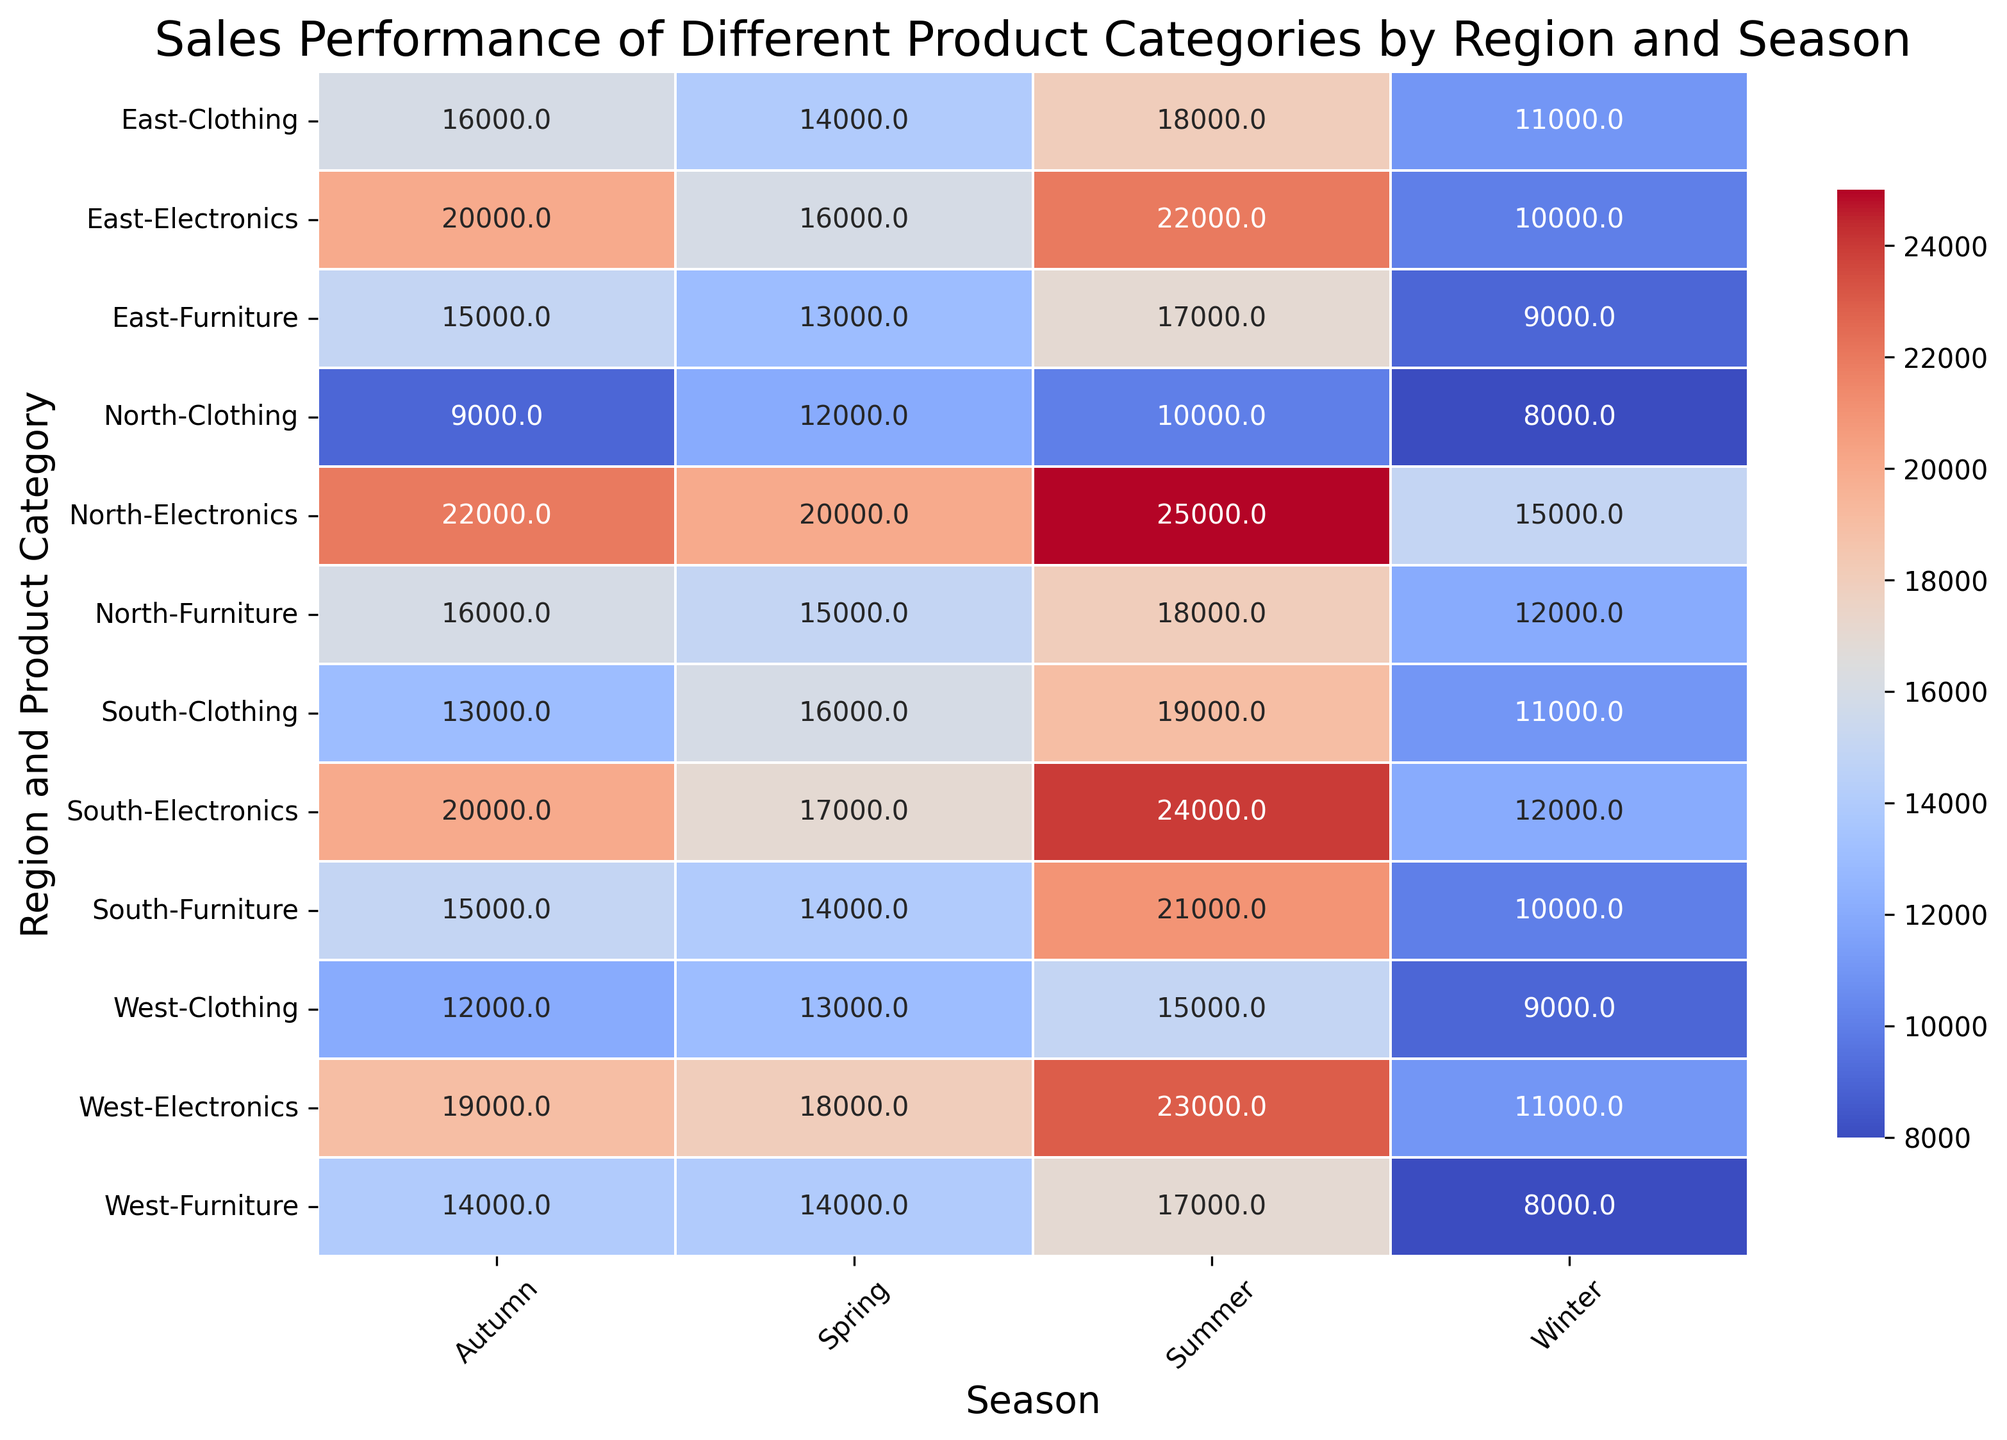What's the total sales for Electronics in North during Winter and Spring? To find this, sum the sales of Electronics in North during Winter (15000) and Spring (20000). The total sales are 15000 + 20000 = 35000.
Answer: 35000 Which region had the highest sales for Furniture in Summer? Examine the values for Furniture in Summer across all regions. The highest sales are in the South with 21000.
Answer: South What's the difference in Clothing sales between East and West in Autumn? Look at the Clothing sales in Autumn for East (16000) and West (12000). The difference is calculated as 16000 - 12000 = 4000.
Answer: 4000 Which season had the overall highest sales for any product category for the West region? Check all seasons for the highest sales in any product category in the West. Summer has the highest sales with Electronics at 23000.
Answer: Summer What's the sum of Clothing sales across all regions in Winter? Sum the Clothing sales in Winter for North (8000), South (11000), East (11000), and West (9000). The total is 8000 + 11000 + 11000 + 9000 = 39000.
Answer: 39000 Compare the sales performance of Electronics in Spring between North and East. Which one is higher? Compare the sales for Electronics in Spring between North (20000) and East (16000). North has higher sales.
Answer: North How does the color intensity of the heatmap correlate with sales values? Darker colors in the heatmap indicate higher sales values, and lighter colors indicate lower sales values. For example, deep red represents higher figures, while pale blue represents lower sales figures.
Answer: Darker = Higher, Lighter = Lower What is the average sales for Furniture in the North region across all seasons? Calculate the average by summing up the Furniture sales in North (12000 in Winter, 15000 in Spring, 18000 in Summer, 16000 in Autumn) and dividing by 4. The average is (12000 + 15000 + 18000 + 16000) / 4 = 15250.
Answer: 15250 Which product category in the South had the lowest sales in Autumn? Identify the lowest sales value among Electronics (20000), Furniture (15000), and Clothing (13000) in the South during Autumn. Clothing has the lowest sales.
Answer: Clothing 